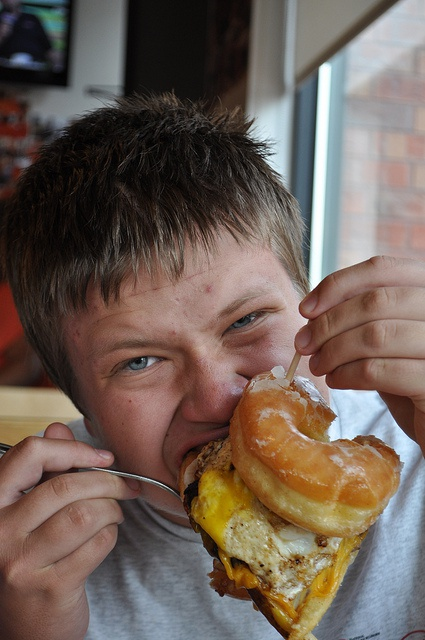Describe the objects in this image and their specific colors. I can see people in black, gray, darkgray, and maroon tones, sandwich in black, olive, tan, maroon, and darkgray tones, donut in black, olive, tan, gray, and maroon tones, and fork in black, gray, maroon, and darkgray tones in this image. 